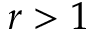<formula> <loc_0><loc_0><loc_500><loc_500>r > 1</formula> 